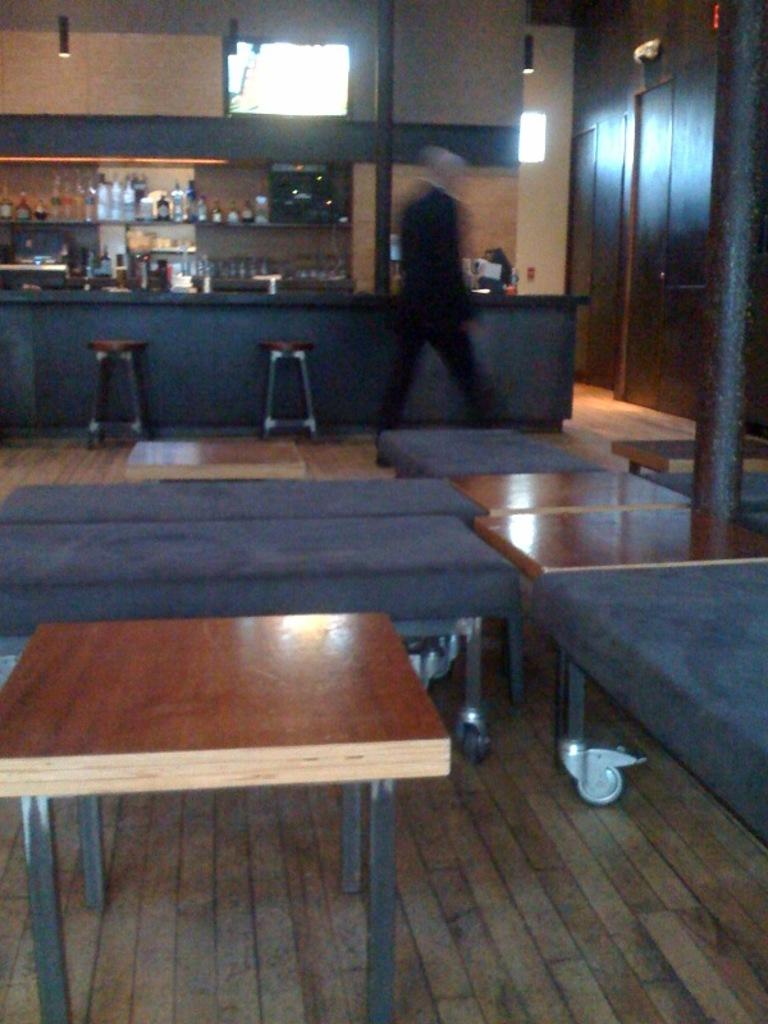What is the position of the man in the image? There is a man on the floor in the image. What type of furniture can be seen in the image? There are tables and stools in the image. What other objects are present in the image? There are poles in the image. What can be seen in the background of the image? There are bottles and a wall in the background of the image. How many dogs are sitting on the stools in the image? There are no dogs present in the image; it only features a man on the floor, tables, stools, poles, bottles, and a wall. 